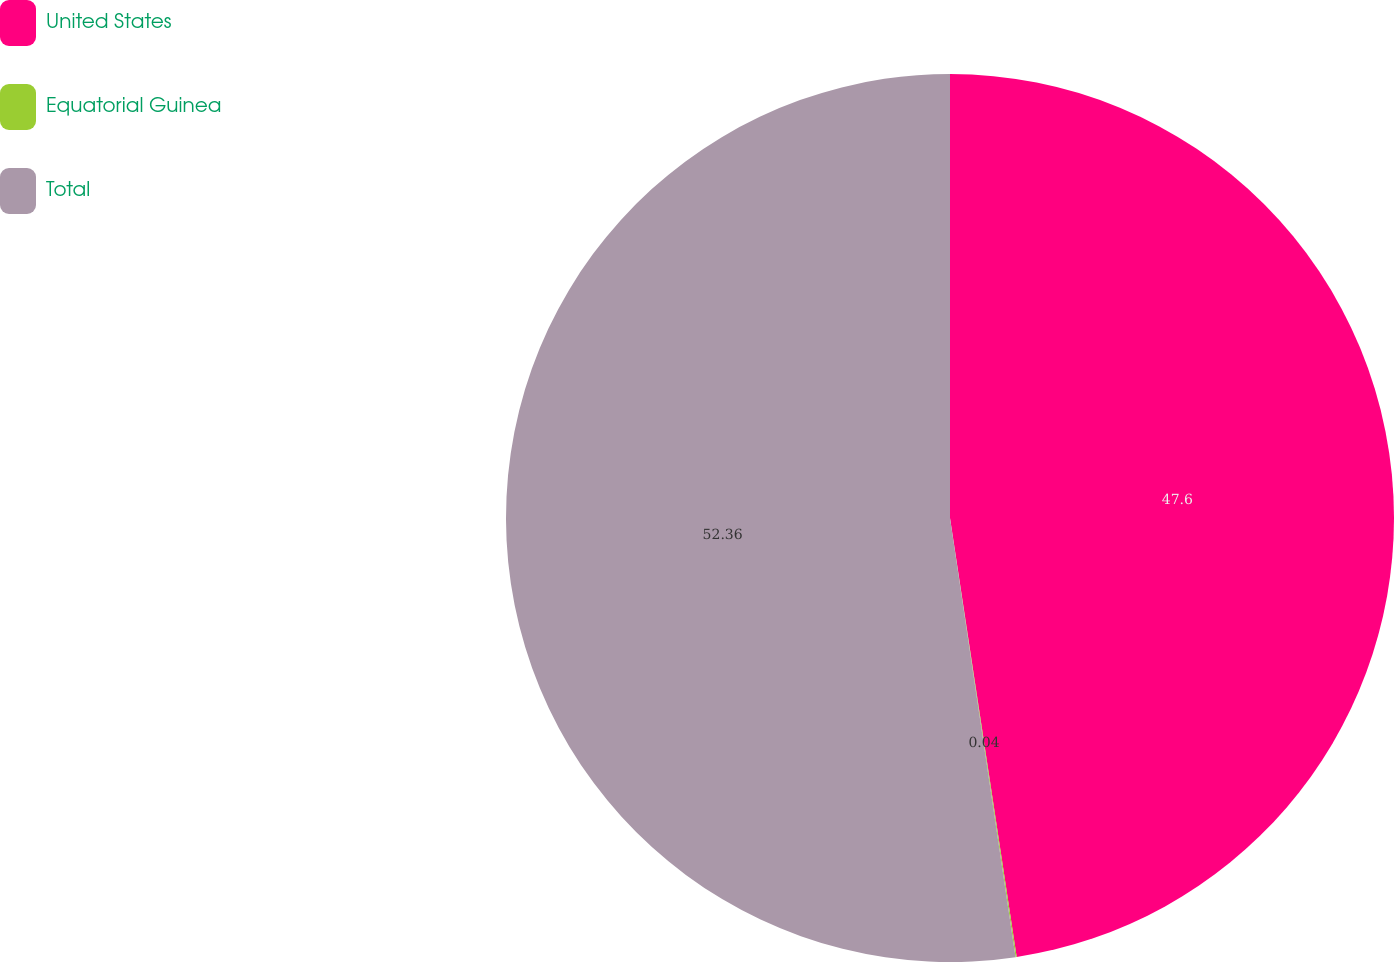<chart> <loc_0><loc_0><loc_500><loc_500><pie_chart><fcel>United States<fcel>Equatorial Guinea<fcel>Total<nl><fcel>47.6%<fcel>0.04%<fcel>52.36%<nl></chart> 